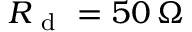<formula> <loc_0><loc_0><loc_500><loc_500>R _ { d } = 5 0 \, \Omega</formula> 